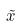<formula> <loc_0><loc_0><loc_500><loc_500>\tilde { x }</formula> 